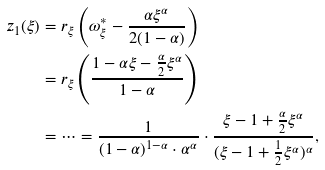<formula> <loc_0><loc_0><loc_500><loc_500>z _ { 1 } ( \xi ) & = r _ { \xi } \left ( \omega _ { \xi } ^ { \ast } - \frac { \alpha \xi ^ { \alpha } } { 2 ( 1 - \alpha ) } \right ) \\ & = r _ { \xi } \left ( \frac { 1 - \alpha \xi - \frac { \alpha } { 2 } \xi ^ { \alpha } } { 1 - \alpha } \right ) \\ & = \dots = \frac { 1 } { ( 1 - \alpha ) ^ { 1 - \alpha } \cdot \alpha ^ { \alpha } } \cdot \frac { \xi - 1 + \frac { \alpha } { 2 } \xi ^ { \alpha } } { ( \xi - 1 + \frac { 1 } { 2 } \xi ^ { \alpha } ) ^ { \alpha } } ,</formula> 